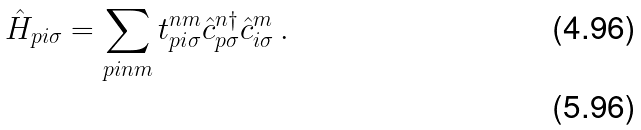Convert formula to latex. <formula><loc_0><loc_0><loc_500><loc_500>\hat { H } _ { p i \sigma } = \sum _ { { p i } n m } t _ { { p i } \sigma } ^ { n m } \hat { c } _ { { p } \sigma } ^ { n \dag } \hat { c } _ { { i } \sigma } ^ { m } \, . \\</formula> 